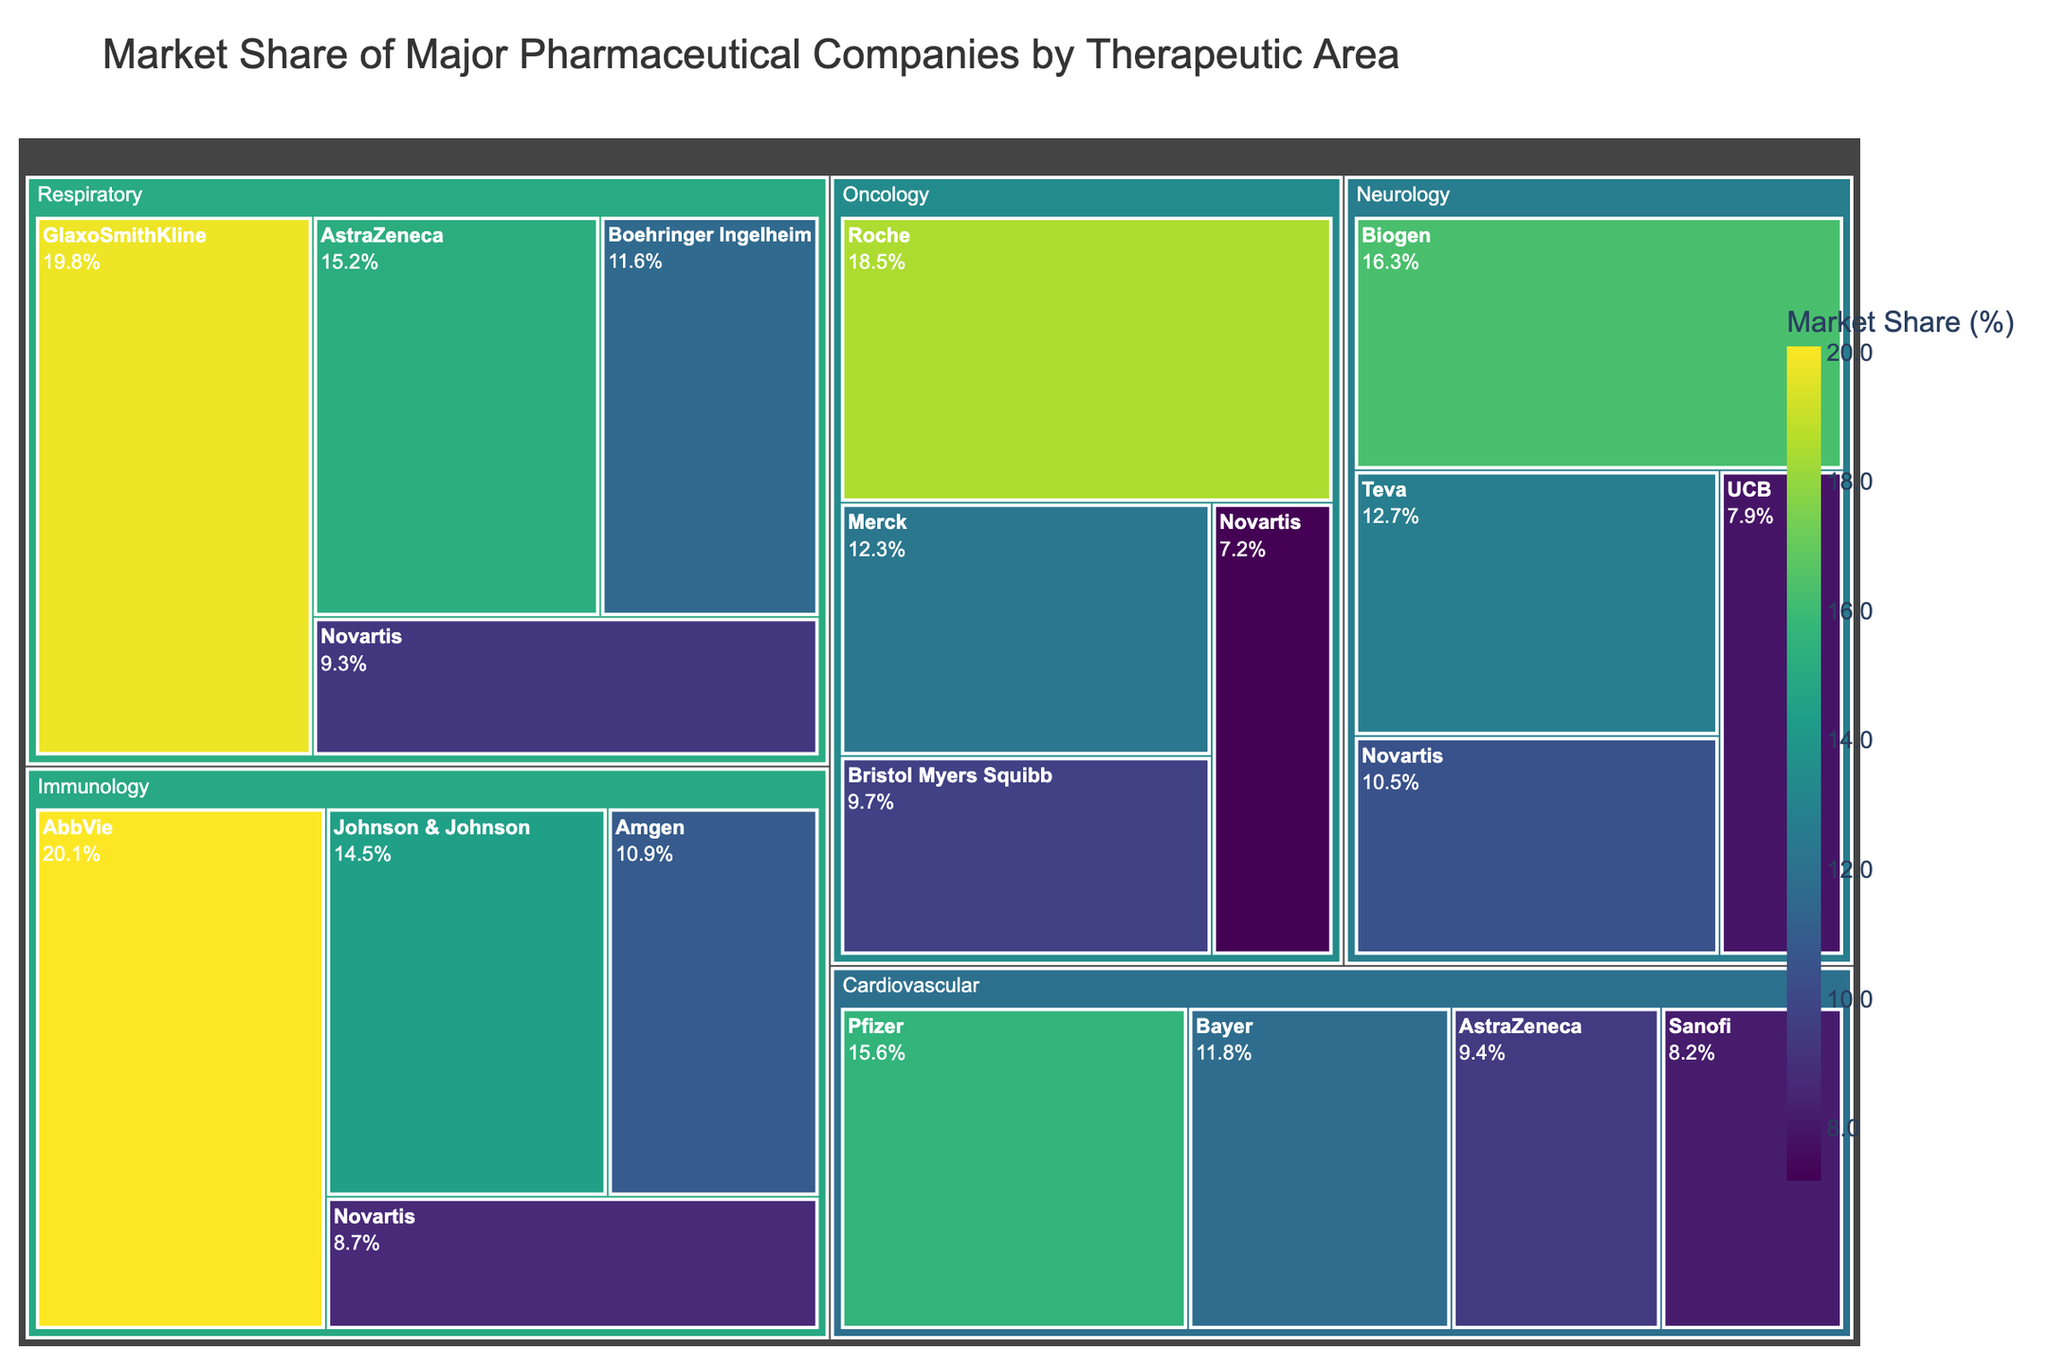What's the overall theme of the figure? The title at the top of the figure states "Market Share of Major Pharmaceutical Companies by Therapeutic Area," indicating that the focus is on the market share distribution of pharmaceutical companies across various therapeutic areas.
Answer: Market share distribution across therapeutic areas Which company has the highest market share in the Immunology therapeutic area? The largest rectangle within the Immunology section is labeled "AbbVie," and it has the highest numerical market share value in Immunology at 20.1%.
Answer: AbbVie What is the market share difference between Roche and Merck in Oncology? According to the rectangles in the Oncology section, Roche's market share is 18.5%, and Merck's is 12.3%. Subtracting these values (18.5 - 12.3) gives 6.2%.
Answer: 6.2% Which company has a larger market share in Neurology: Biogen or Teva? The Neurology section shows the market shares for Biogen and Teva. Biogen has 16.3%, and Teva has 12.7%. Since 16.3% is larger than 12.7%, Biogen has a larger market share in Neurology.
Answer: Biogen How does the market share of AstraZeneca in Cardiovascular compare to that in Respiratory? AstraZeneca's market share is 9.4% in Cardiovascular and 15.2% in Respiratory. Since 15.2% is greater than 9.4%, AstraZeneca has a larger market share in Respiratory.
Answer: Larger in Respiratory What is the combined market share of the top two companies in Respiratory? The top two companies in Respiratory are GlaxoSmithKline with 19.8% and AstraZeneca with 15.2%. Adding these values (19.8 + 15.2) gives a combined market share of 35%.
Answer: 35% How many companies hold over 10% market share in Cardiovascular? The Cardiovascular section shows that Pfizer, Bayer, and AstraZeneca each have market shares above 10%, while Sanofi has 8.2%. Therefore, there are three companies with over 10% market share.
Answer: 3 What is the smallest market share value mentioned in the figure? Among all therapeutic areas and companies listed, the smallest market share value is 7.2%, which belongs to Novartis in Oncology.
Answer: 7.2% Which company holds the highest market share among all therapeutic areas mentioned? The largest market share values across all therapeutic areas are examined. AbbVie holds the highest at 20.1% in Immunology, which is the highest individual value in the figure.
Answer: AbbVie 